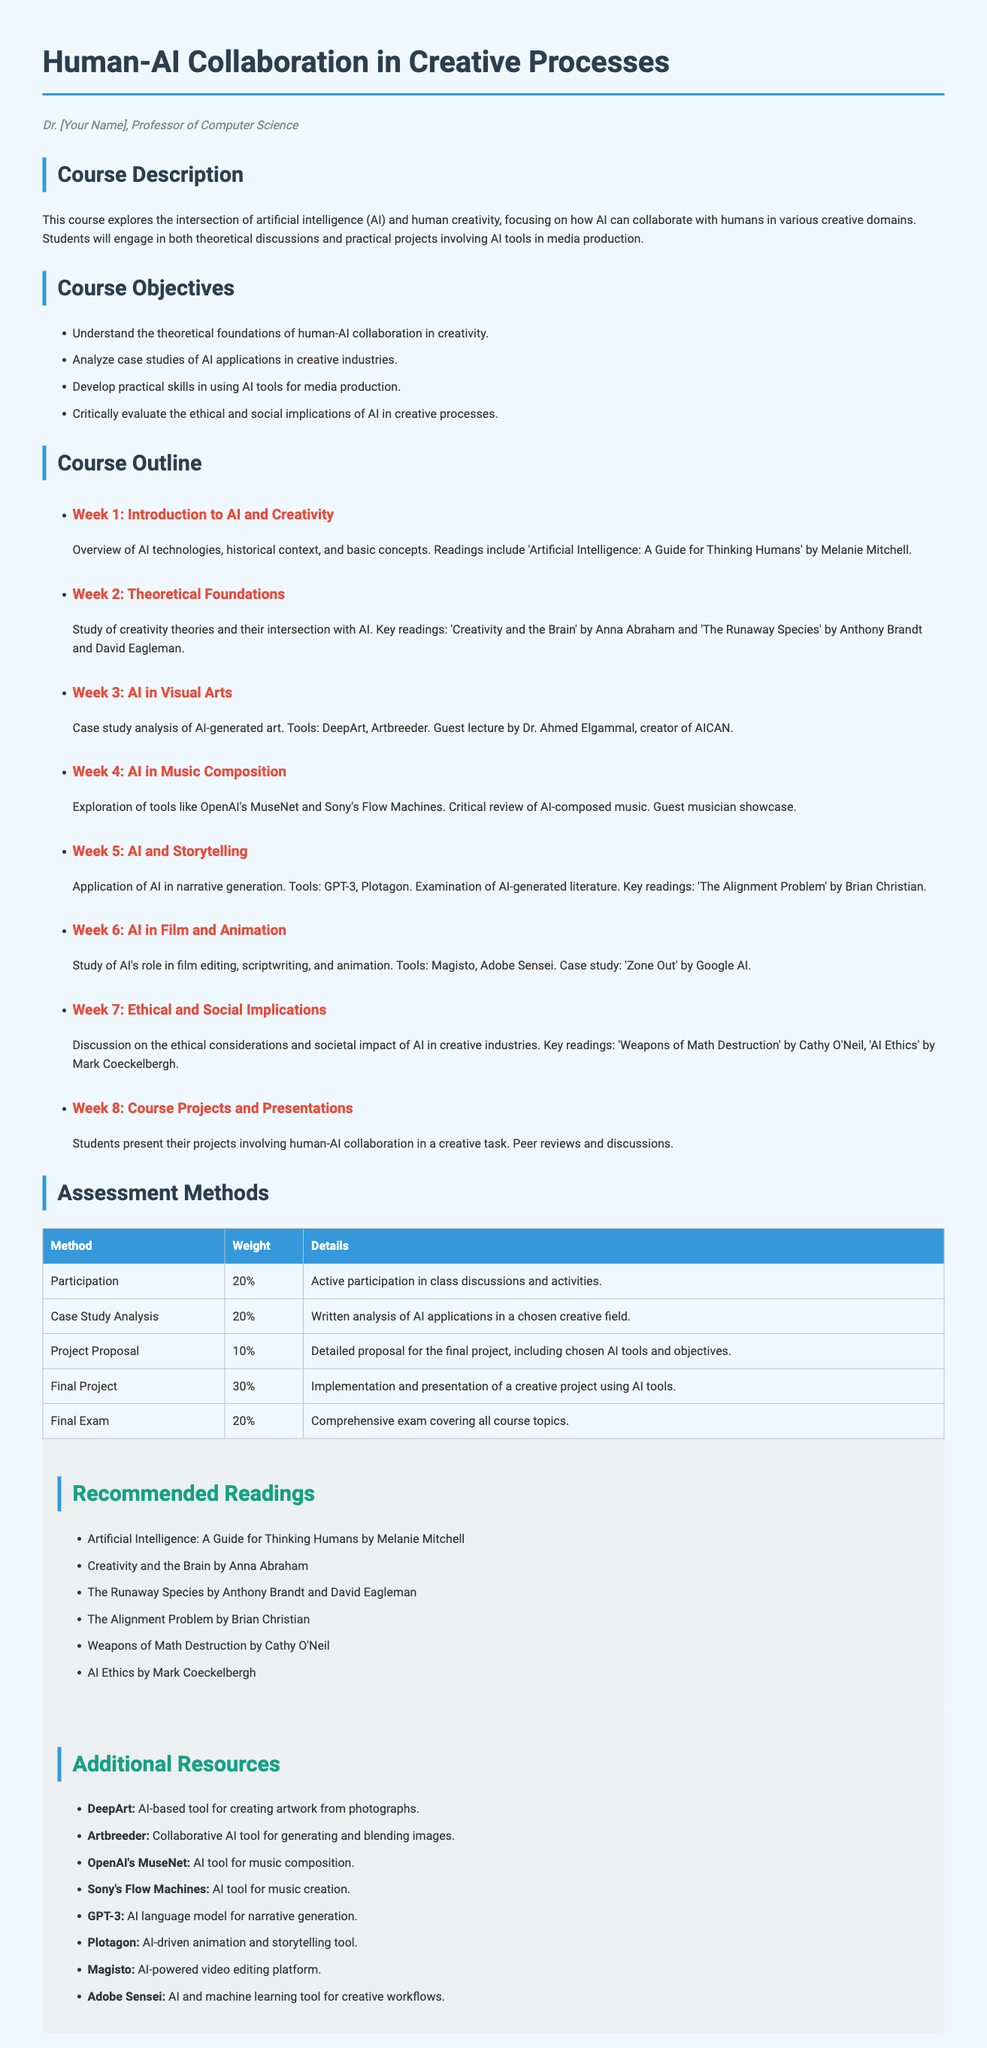What is the title of the course? The title is explicitly stated in the document heading as "Human-AI Collaboration in Creative Processes."
Answer: Human-AI Collaboration in Creative Processes Who is the instructor? The instructor's name is provided in the header of the syllabus.
Answer: Dr. [Your Name] What is the weight of the final project in the assessment methods? The weight of the final project is listed as 30% in the assessment table.
Answer: 30% Which reading discusses the intersection of creativity and the brain? A specific reading is mentioned in the course outline under Week 2, titled "Creativity and the Brain."
Answer: Creativity and the Brain What is the focus of Week 5 in the course outline? Week 5 discusses the application of AI in narrative generation, which is stated in the outline.
Answer: AI and Storytelling What AI tool is mentioned for creating artwork from photographs? The syllabus specifically lists DeepArt as the AI-based tool for this purpose.
Answer: DeepArt How many weeks does the course span? The course outline lists eight distinct weeks, indicating its total duration.
Answer: 8 What is the percentage weight for participation in the assessment? The weight for participation is explicitly defined as 20% in the assessment section.
Answer: 20% 